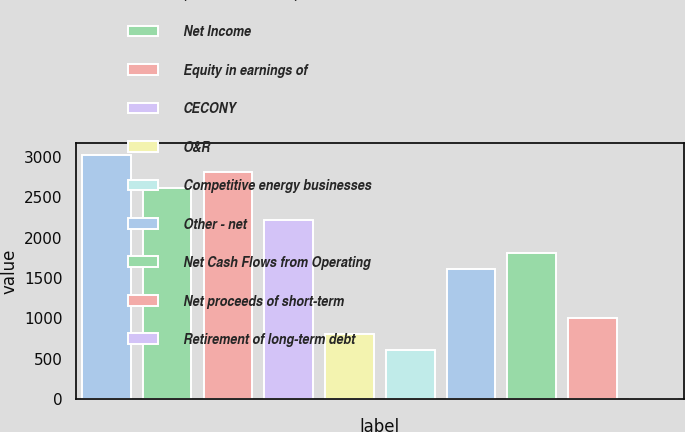Convert chart. <chart><loc_0><loc_0><loc_500><loc_500><bar_chart><fcel>(Millions of Dollars)<fcel>Net Income<fcel>Equity in earnings of<fcel>CECONY<fcel>O&R<fcel>Competitive energy businesses<fcel>Other - net<fcel>Net Cash Flows from Operating<fcel>Net proceeds of short-term<fcel>Retirement of long-term debt<nl><fcel>3017.5<fcel>2615.3<fcel>2816.4<fcel>2213.1<fcel>805.4<fcel>604.3<fcel>1609.8<fcel>1810.9<fcel>1006.5<fcel>1<nl></chart> 